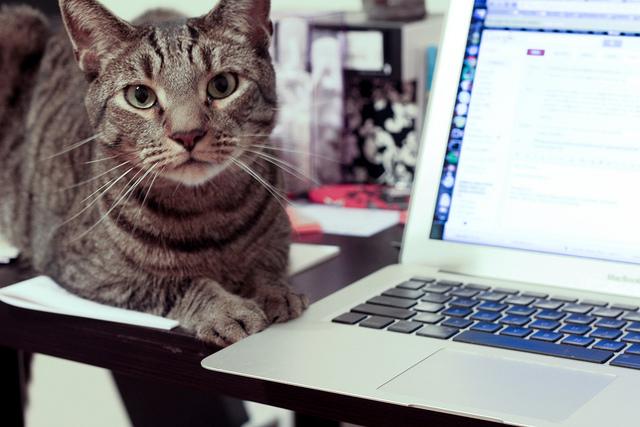Is the cat sitting on a bar stool?
Keep it brief. No. Is this cat awake?
Short answer required. Yes. Is the computer on?
Write a very short answer. Yes. Can the cat use the computer?
Concise answer only. No. Is a spreadsheet on the screen?
Be succinct. No. 